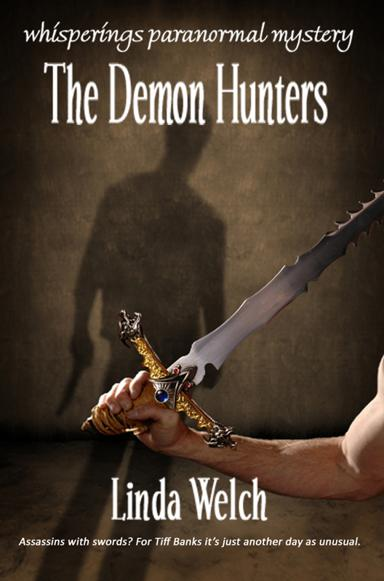What can you tell me about the main character, Tiff Banks? Tiff Banks, the protagonist of 'The Demon Hunters,' appears to be entwined in a world brimming with supernatural elements and dark adversaries, as hinted by the shadowy figure and the looming threat of assassins with swords. Her day-to-day life likely oscillates between conventional existence and high-stake paranormal encounters, painting her as a character of resilience and intrigue. 